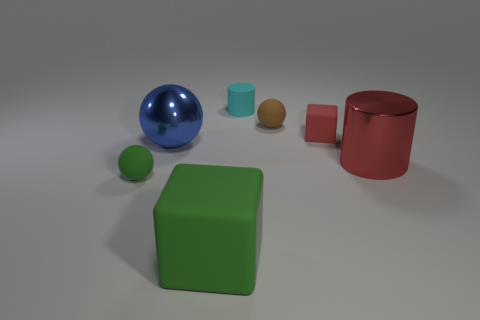How many objects are either green shiny objects or rubber cubes to the right of the big cube?
Your response must be concise. 1. Does the large blue sphere have the same material as the red cylinder?
Your response must be concise. Yes. How many other objects are there of the same shape as the tiny red thing?
Your answer should be very brief. 1. There is a rubber thing that is to the right of the tiny matte cylinder and left of the red cube; what size is it?
Provide a short and direct response. Small. How many rubber objects are small green things or large red cylinders?
Your answer should be compact. 1. Is the shape of the green rubber object that is left of the big blue metallic object the same as the big shiny object right of the small brown rubber object?
Provide a succinct answer. No. Are there any other green balls that have the same material as the big ball?
Make the answer very short. No. What is the color of the big matte thing?
Your response must be concise. Green. There is a red cylinder that is right of the large cube; what is its size?
Provide a short and direct response. Large. How many balls have the same color as the big cylinder?
Offer a very short reply. 0. 